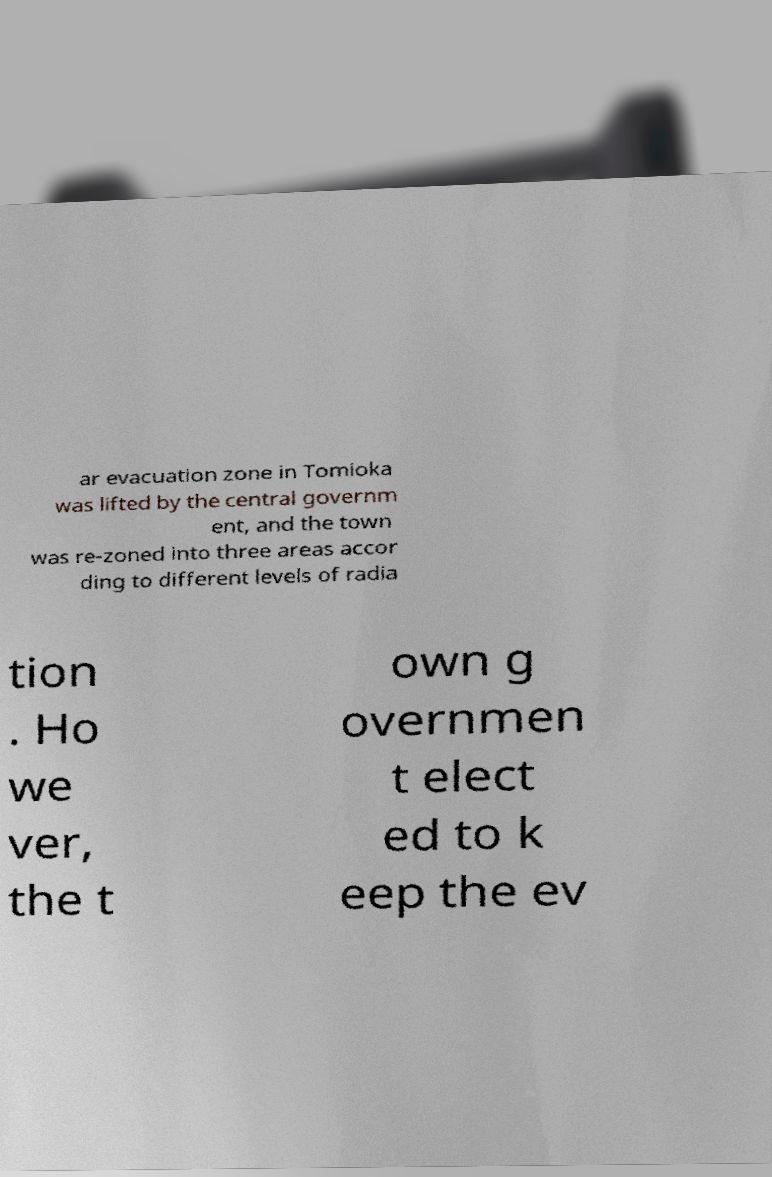What messages or text are displayed in this image? I need them in a readable, typed format. ar evacuation zone in Tomioka was lifted by the central governm ent, and the town was re-zoned into three areas accor ding to different levels of radia tion . Ho we ver, the t own g overnmen t elect ed to k eep the ev 